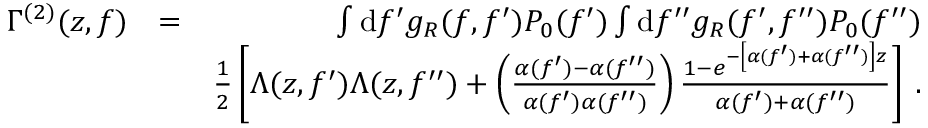<formula> <loc_0><loc_0><loc_500><loc_500>\begin{array} { r l r } { \Gamma ^ { ( 2 ) } ( z , f ) } & { = } & { \int d f ^ { \prime } g _ { R } ( f , f ^ { \prime } ) P _ { 0 } ( f ^ { \prime } ) \int d f ^ { \prime \prime } g _ { R } ( f ^ { \prime } , f ^ { \prime \prime } ) P _ { 0 } ( f ^ { \prime \prime } ) } \\ & { \frac { 1 } { 2 } \left [ \Lambda ( z , f ^ { \prime } ) \Lambda ( z , f ^ { \prime \prime } ) + \left ( \frac { \alpha ( f ^ { \prime } ) - \alpha ( f ^ { \prime \prime } ) } { \alpha ( f ^ { \prime } ) \alpha ( f ^ { \prime \prime } ) } \right ) \frac { 1 - e ^ { - \left [ \alpha ( f ^ { \prime } ) + \alpha ( f ^ { \prime \prime } ) \right ] z } } { \alpha ( f ^ { \prime } ) + \alpha ( f ^ { \prime \prime } ) } \right ] \, . } \end{array}</formula> 